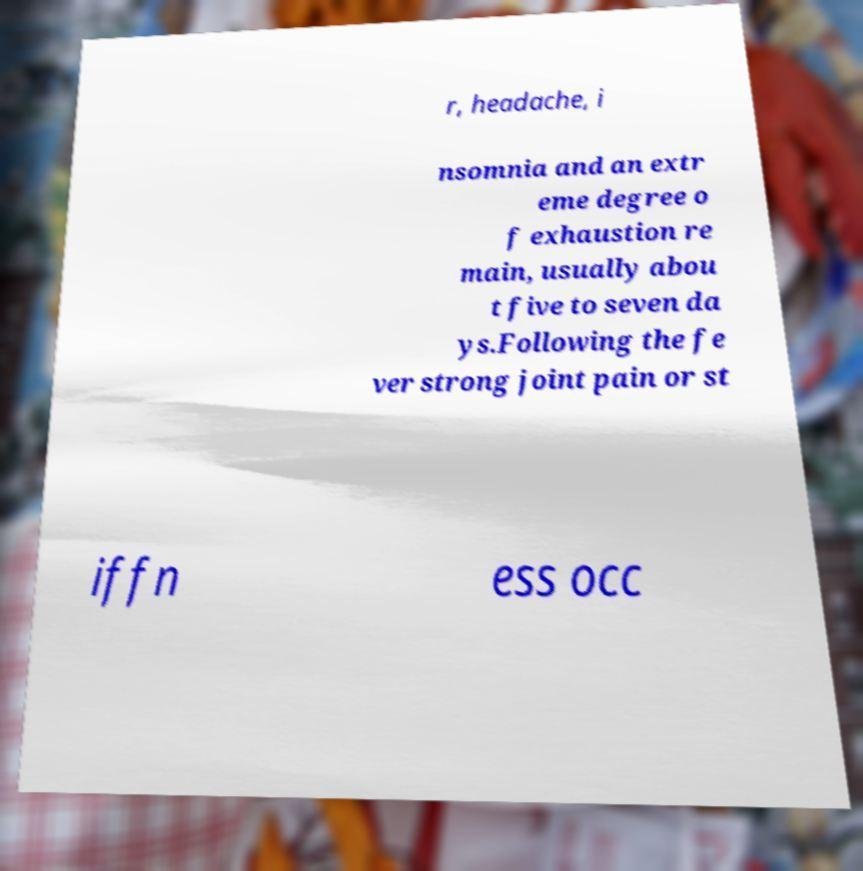What messages or text are displayed in this image? I need them in a readable, typed format. r, headache, i nsomnia and an extr eme degree o f exhaustion re main, usually abou t five to seven da ys.Following the fe ver strong joint pain or st iffn ess occ 